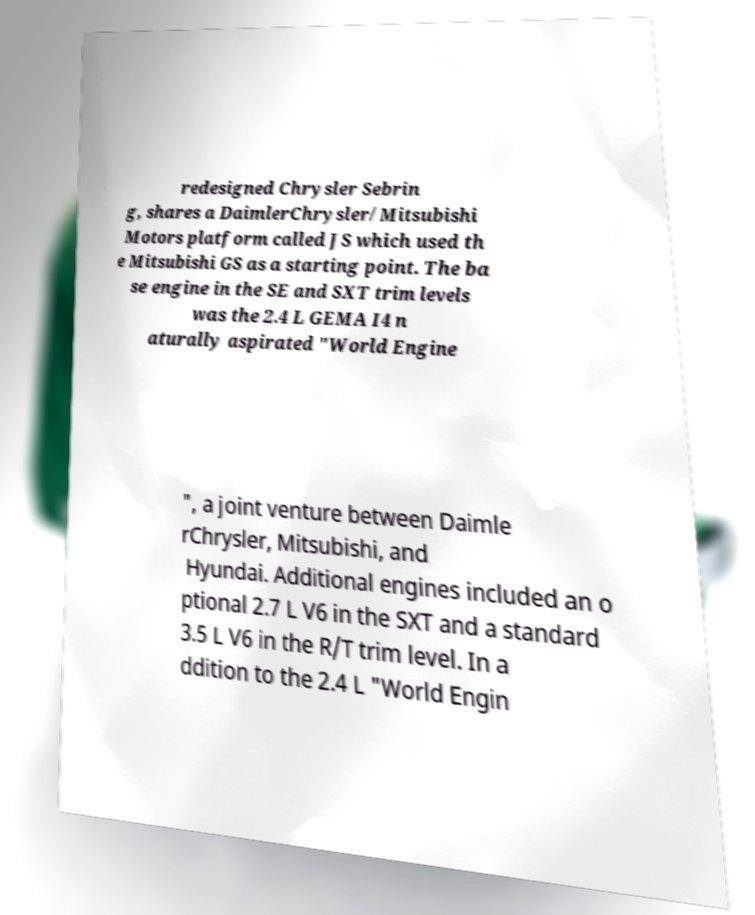Can you read and provide the text displayed in the image?This photo seems to have some interesting text. Can you extract and type it out for me? redesigned Chrysler Sebrin g, shares a DaimlerChrysler/Mitsubishi Motors platform called JS which used th e Mitsubishi GS as a starting point. The ba se engine in the SE and SXT trim levels was the 2.4 L GEMA I4 n aturally aspirated "World Engine ", a joint venture between Daimle rChrysler, Mitsubishi, and Hyundai. Additional engines included an o ptional 2.7 L V6 in the SXT and a standard 3.5 L V6 in the R/T trim level. In a ddition to the 2.4 L "World Engin 